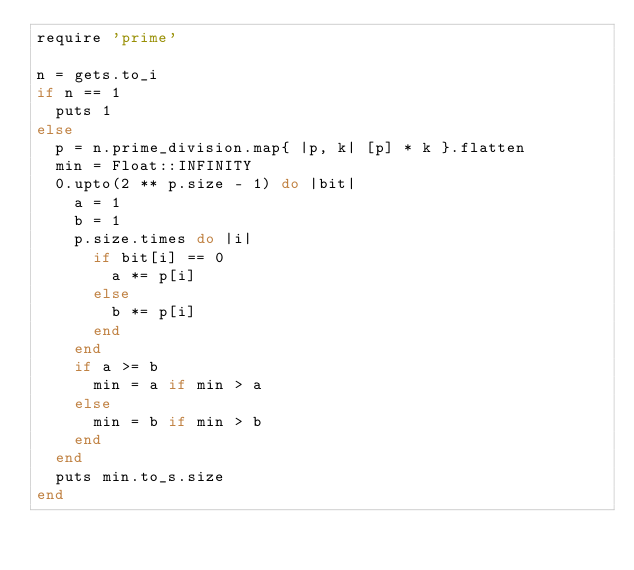<code> <loc_0><loc_0><loc_500><loc_500><_Ruby_>require 'prime'

n = gets.to_i
if n == 1
  puts 1
else
  p = n.prime_division.map{ |p, k| [p] * k }.flatten
  min = Float::INFINITY
  0.upto(2 ** p.size - 1) do |bit|
    a = 1
    b = 1
    p.size.times do |i|
      if bit[i] == 0
        a *= p[i]
      else
        b *= p[i]
      end
    end
    if a >= b
      min = a if min > a
    else
      min = b if min > b
    end
  end
  puts min.to_s.size
end</code> 